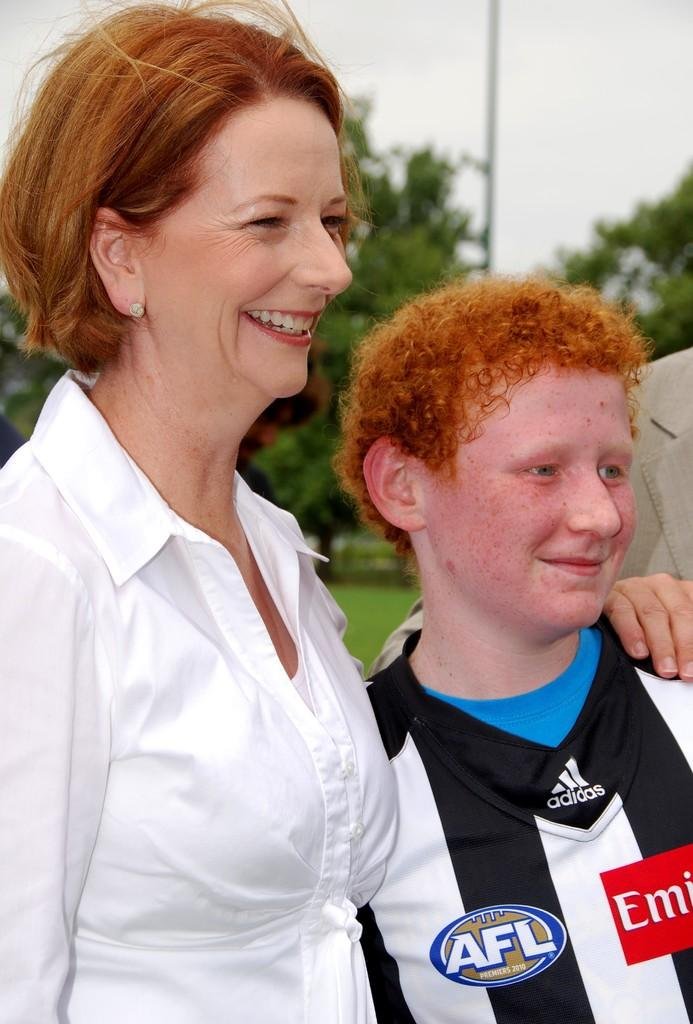Provide a one-sentence caption for the provided image. A woman standing next to a young man in a Adidas referee jersey. 